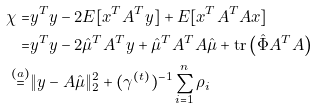<formula> <loc_0><loc_0><loc_500><loc_500>\chi = & y ^ { T } y - 2 E [ x ^ { T } A ^ { T } y ] + E [ x ^ { T } A ^ { T } A x ] \\ = & y ^ { T } y - 2 \hat { \mu } ^ { T } A ^ { T } y + \hat { \mu } ^ { T } A ^ { T } A \hat { \mu } + \text {tr} \left ( \hat { \Phi } A ^ { T } A \right ) \\ \stackrel { ( a ) } { = } & \| y - A \hat { \mu } \| _ { 2 } ^ { 2 } + ( \gamma ^ { ( t ) } ) ^ { - 1 } \sum _ { i = 1 } ^ { n } \rho _ { i }</formula> 